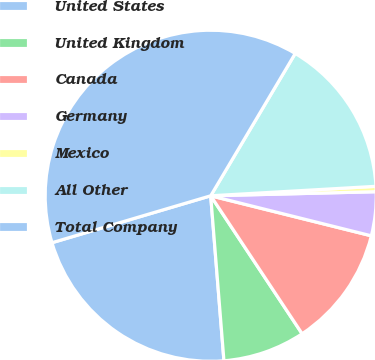<chart> <loc_0><loc_0><loc_500><loc_500><pie_chart><fcel>United States<fcel>United Kingdom<fcel>Canada<fcel>Germany<fcel>Mexico<fcel>All Other<fcel>Total Company<nl><fcel>21.7%<fcel>8.04%<fcel>11.8%<fcel>4.28%<fcel>0.52%<fcel>15.56%<fcel>38.11%<nl></chart> 